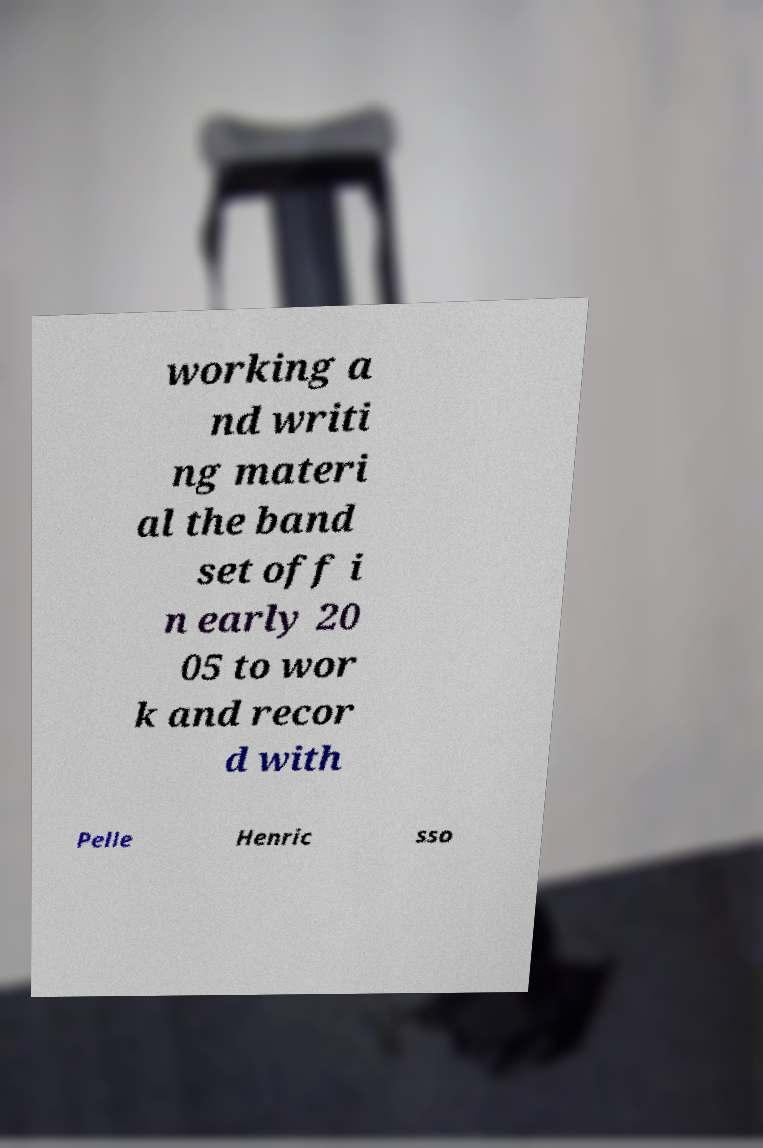Can you read and provide the text displayed in the image?This photo seems to have some interesting text. Can you extract and type it out for me? working a nd writi ng materi al the band set off i n early 20 05 to wor k and recor d with Pelle Henric sso 